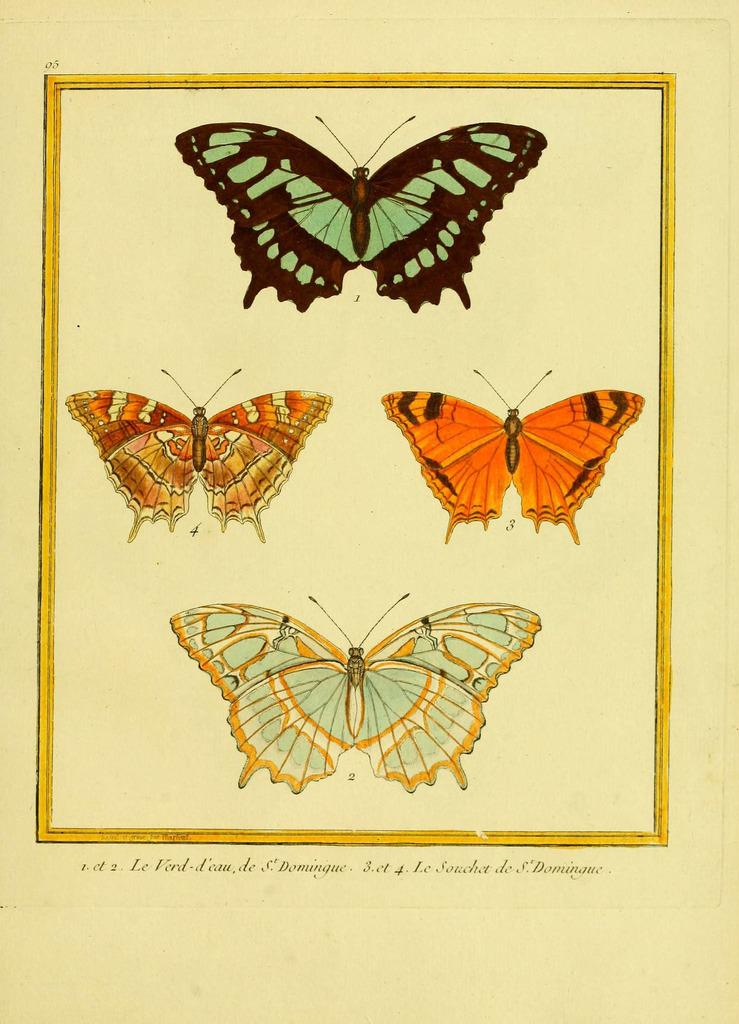What is in the foreground of the image? There are four butterflies and text present in the foreground of the image. Can you describe the butterflies in the image? There are four butterflies in the foreground of the image. Can you tell me how many planes are flying over the stream in the image? There is no stream or planes present in the image; it features four butterflies and text in the foreground. 